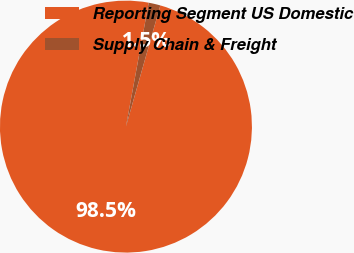Convert chart to OTSL. <chart><loc_0><loc_0><loc_500><loc_500><pie_chart><fcel>Reporting Segment US Domestic<fcel>Supply Chain & Freight<nl><fcel>98.49%<fcel>1.51%<nl></chart> 